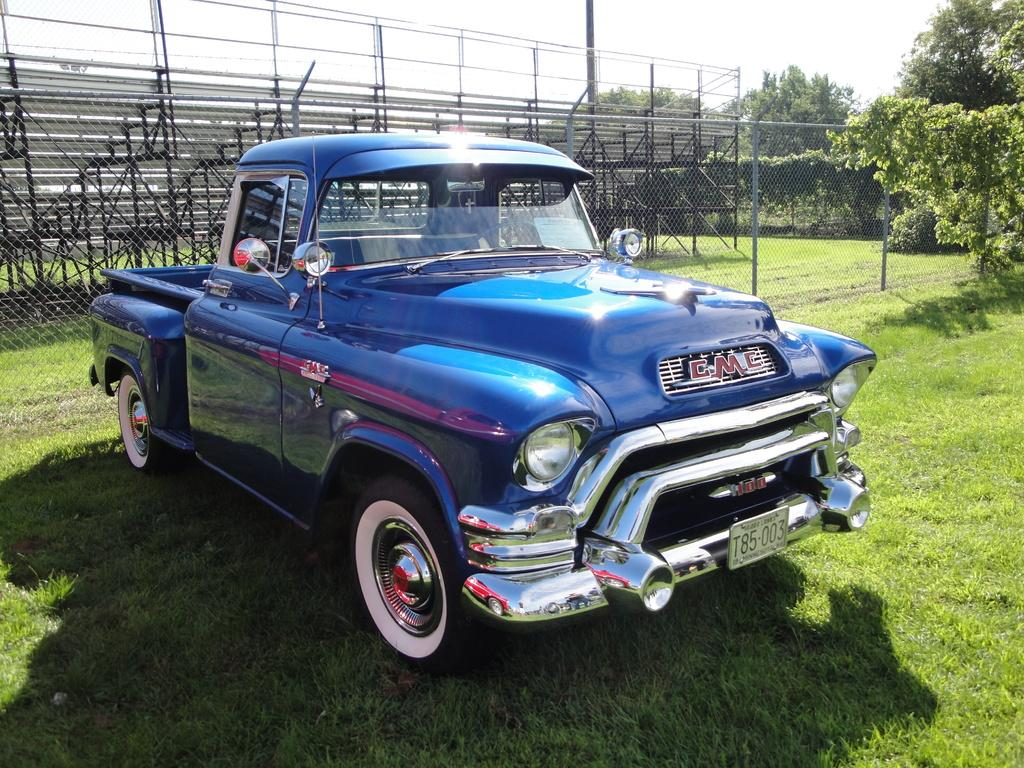What is the car parked on in the image? The car is parked on the grass in the image. How is the car positioned on the grass? The car is parked on the surface of the grass. What type of fencing is visible behind the car? There is fencing with metal rods behind the car. What can be seen in the background of the image? Trees and the sky are visible in the background of the image. What type of marble is used to decorate the car's interior in the image? There is no marble mentioned or visible in the image; it only shows a car parked on the grass with fencing and trees in the background. 